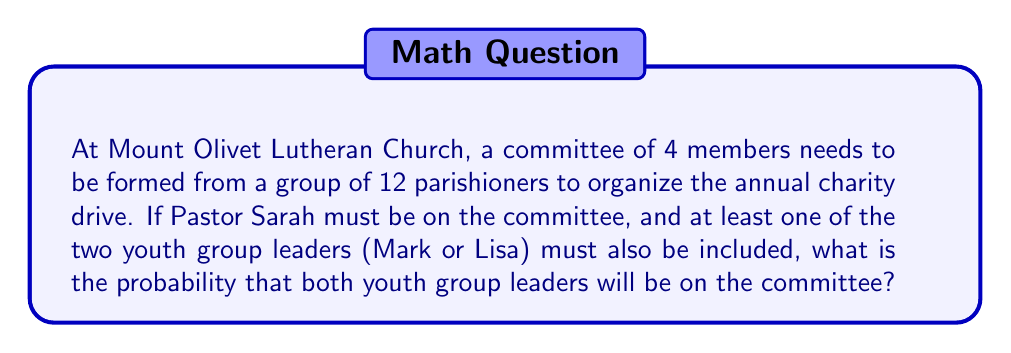Can you solve this math problem? Let's approach this step-by-step:

1) First, we know that Pastor Sarah must be on the committee, so we have 1 position filled and 3 left to fill.

2) We also know that at least one of Mark or Lisa must be on the committee. To find the probability that both are on the committee, we can consider this scenario:
   - Pastor Sarah is on the committee (already given)
   - Both Mark and Lisa are on the committee
   - We need to select 1 more person from the remaining 9 parishioners

3) To calculate this, we can use the combination formula:

   $$\binom{9}{1} = \frac{9!}{1!(9-1)!} = 9$$

4) Now, let's consider the total number of possible committees that satisfy the given conditions:
   - Pastor Sarah is on the committee
   - At least one of Mark or Lisa is on the committee
   
   We can calculate this by subtracting the number of committees with neither Mark nor Lisa from all possible committees:

   $$\binom{11}{3} - \binom{9}{3} = 165 - 84 = 81$$

5) The probability is then the number of favorable outcomes divided by the total number of possible outcomes:

   $$P(\text{both Mark and Lisa on committee}) = \frac{9}{81} = \frac{1}{9}$$
Answer: $\frac{1}{9}$ or approximately $0.1111$ 